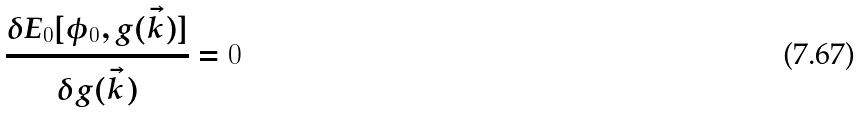Convert formula to latex. <formula><loc_0><loc_0><loc_500><loc_500>\frac { \delta E _ { 0 } [ \phi _ { 0 } , g ( \vec { k } ) ] } { \delta g ( \vec { k } ) } = 0</formula> 